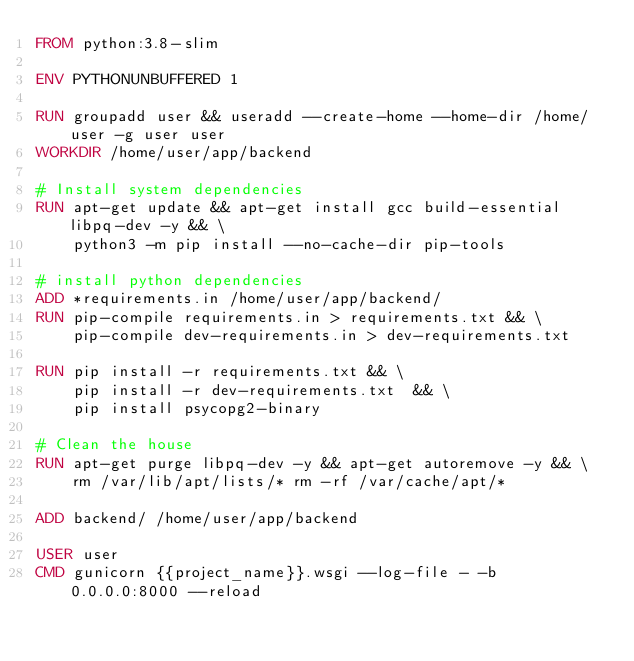Convert code to text. <code><loc_0><loc_0><loc_500><loc_500><_Dockerfile_>FROM python:3.8-slim

ENV PYTHONUNBUFFERED 1

RUN groupadd user && useradd --create-home --home-dir /home/user -g user user
WORKDIR /home/user/app/backend

# Install system dependencies
RUN apt-get update && apt-get install gcc build-essential libpq-dev -y && \
    python3 -m pip install --no-cache-dir pip-tools

# install python dependencies
ADD *requirements.in /home/user/app/backend/
RUN pip-compile requirements.in > requirements.txt && \
    pip-compile dev-requirements.in > dev-requirements.txt

RUN pip install -r requirements.txt && \
    pip install -r dev-requirements.txt  && \
    pip install psycopg2-binary

# Clean the house
RUN apt-get purge libpq-dev -y && apt-get autoremove -y && \
    rm /var/lib/apt/lists/* rm -rf /var/cache/apt/*

ADD backend/ /home/user/app/backend

USER user
CMD gunicorn {{project_name}}.wsgi --log-file - -b 0.0.0.0:8000 --reload
</code> 